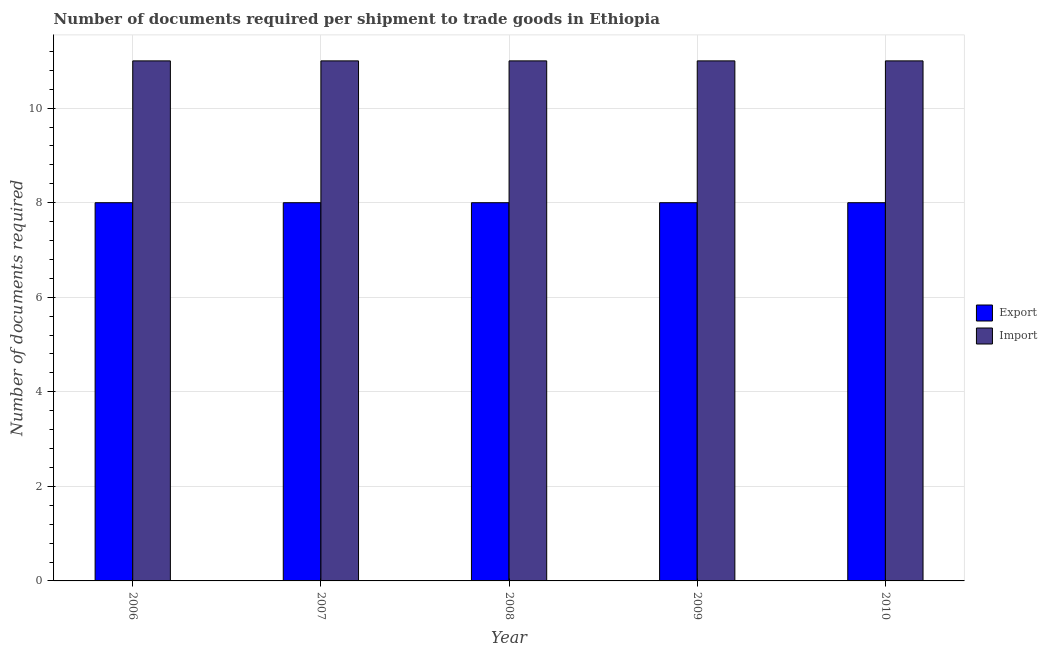How many different coloured bars are there?
Ensure brevity in your answer.  2. How many groups of bars are there?
Make the answer very short. 5. Are the number of bars on each tick of the X-axis equal?
Your answer should be very brief. Yes. How many bars are there on the 5th tick from the left?
Offer a very short reply. 2. How many bars are there on the 4th tick from the right?
Your answer should be very brief. 2. What is the label of the 5th group of bars from the left?
Offer a very short reply. 2010. What is the number of documents required to export goods in 2008?
Your answer should be compact. 8. Across all years, what is the maximum number of documents required to import goods?
Offer a very short reply. 11. Across all years, what is the minimum number of documents required to import goods?
Provide a succinct answer. 11. In which year was the number of documents required to export goods minimum?
Your answer should be compact. 2006. What is the total number of documents required to import goods in the graph?
Ensure brevity in your answer.  55. What is the difference between the number of documents required to export goods in 2008 and the number of documents required to import goods in 2010?
Make the answer very short. 0. What is the average number of documents required to import goods per year?
Make the answer very short. 11. In how many years, is the number of documents required to import goods greater than 2?
Keep it short and to the point. 5. What is the ratio of the number of documents required to import goods in 2006 to that in 2007?
Offer a very short reply. 1. Is the difference between the number of documents required to export goods in 2006 and 2008 greater than the difference between the number of documents required to import goods in 2006 and 2008?
Your answer should be compact. No. Is the sum of the number of documents required to import goods in 2006 and 2009 greater than the maximum number of documents required to export goods across all years?
Your answer should be compact. Yes. What does the 1st bar from the left in 2006 represents?
Make the answer very short. Export. What does the 2nd bar from the right in 2007 represents?
Make the answer very short. Export. How many years are there in the graph?
Offer a terse response. 5. Are the values on the major ticks of Y-axis written in scientific E-notation?
Give a very brief answer. No. Does the graph contain any zero values?
Make the answer very short. No. Does the graph contain grids?
Provide a succinct answer. Yes. How many legend labels are there?
Offer a terse response. 2. How are the legend labels stacked?
Provide a succinct answer. Vertical. What is the title of the graph?
Provide a short and direct response. Number of documents required per shipment to trade goods in Ethiopia. Does "Infant" appear as one of the legend labels in the graph?
Make the answer very short. No. What is the label or title of the X-axis?
Your answer should be compact. Year. What is the label or title of the Y-axis?
Provide a succinct answer. Number of documents required. What is the Number of documents required in Export in 2006?
Your response must be concise. 8. What is the Number of documents required in Import in 2008?
Offer a terse response. 11. What is the Number of documents required in Export in 2009?
Offer a terse response. 8. What is the Number of documents required in Export in 2010?
Offer a terse response. 8. What is the Number of documents required in Import in 2010?
Ensure brevity in your answer.  11. Across all years, what is the maximum Number of documents required of Import?
Offer a terse response. 11. What is the difference between the Number of documents required in Export in 2006 and that in 2007?
Offer a terse response. 0. What is the difference between the Number of documents required in Import in 2006 and that in 2008?
Provide a succinct answer. 0. What is the difference between the Number of documents required in Export in 2006 and that in 2009?
Your answer should be very brief. 0. What is the difference between the Number of documents required of Export in 2007 and that in 2008?
Your response must be concise. 0. What is the difference between the Number of documents required of Export in 2007 and that in 2009?
Offer a terse response. 0. What is the difference between the Number of documents required of Import in 2007 and that in 2010?
Your answer should be very brief. 0. What is the difference between the Number of documents required of Export in 2008 and that in 2009?
Offer a very short reply. 0. What is the difference between the Number of documents required of Import in 2008 and that in 2009?
Provide a short and direct response. 0. What is the difference between the Number of documents required in Export in 2009 and that in 2010?
Make the answer very short. 0. What is the difference between the Number of documents required of Export in 2006 and the Number of documents required of Import in 2007?
Give a very brief answer. -3. What is the difference between the Number of documents required in Export in 2006 and the Number of documents required in Import in 2008?
Your answer should be compact. -3. What is the difference between the Number of documents required of Export in 2006 and the Number of documents required of Import in 2009?
Your answer should be compact. -3. What is the difference between the Number of documents required in Export in 2007 and the Number of documents required in Import in 2009?
Provide a short and direct response. -3. In the year 2006, what is the difference between the Number of documents required of Export and Number of documents required of Import?
Offer a very short reply. -3. In the year 2009, what is the difference between the Number of documents required in Export and Number of documents required in Import?
Keep it short and to the point. -3. In the year 2010, what is the difference between the Number of documents required of Export and Number of documents required of Import?
Provide a short and direct response. -3. What is the ratio of the Number of documents required in Export in 2006 to that in 2007?
Give a very brief answer. 1. What is the ratio of the Number of documents required in Import in 2006 to that in 2007?
Offer a very short reply. 1. What is the ratio of the Number of documents required in Import in 2006 to that in 2008?
Your answer should be very brief. 1. What is the ratio of the Number of documents required of Export in 2006 to that in 2009?
Provide a short and direct response. 1. What is the ratio of the Number of documents required of Export in 2007 to that in 2008?
Make the answer very short. 1. What is the ratio of the Number of documents required of Import in 2007 to that in 2008?
Offer a very short reply. 1. What is the ratio of the Number of documents required in Export in 2007 to that in 2009?
Offer a terse response. 1. What is the ratio of the Number of documents required of Export in 2007 to that in 2010?
Keep it short and to the point. 1. What is the ratio of the Number of documents required of Import in 2008 to that in 2009?
Make the answer very short. 1. What is the ratio of the Number of documents required in Export in 2008 to that in 2010?
Provide a succinct answer. 1. What is the ratio of the Number of documents required of Import in 2008 to that in 2010?
Make the answer very short. 1. What is the difference between the highest and the second highest Number of documents required in Export?
Provide a succinct answer. 0. What is the difference between the highest and the second highest Number of documents required of Import?
Offer a very short reply. 0. 